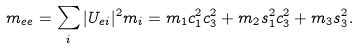<formula> <loc_0><loc_0><loc_500><loc_500>m _ { e e } = \sum _ { i } | U _ { e i } | ^ { 2 } m _ { i } = m _ { 1 } c _ { 1 } ^ { 2 } c _ { 3 } ^ { 2 } + m _ { 2 } s _ { 1 } ^ { 2 } c _ { 3 } ^ { 2 } + m _ { 3 } s _ { 3 } ^ { 2 } .</formula> 